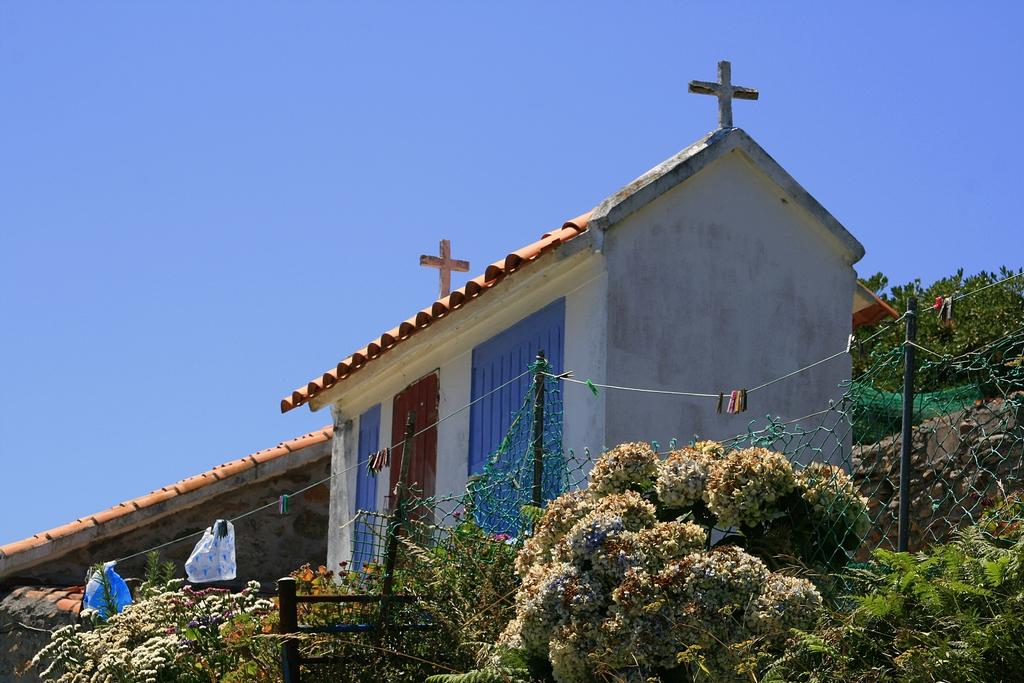What type of vegetation can be seen in the image? There are plants and grass in the image. What type of barrier is present in the image? There is an iron fence in the image. What are the poles used for in the image? The poles are likely used for hanging clothes, as clothes are hanging on ropes in the image. What type of structure is visible in the image? There is a house in the image. What is visible in the sky in the image? The sky is visible in the image. Where is the mother sitting in the image? There is no mother present in the image. What type of board is used for playing games in the image? There is no board present in the image. 